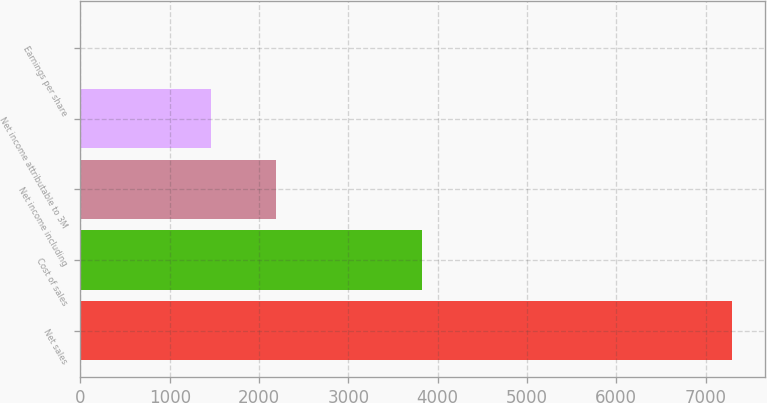<chart> <loc_0><loc_0><loc_500><loc_500><bar_chart><fcel>Net sales<fcel>Cost of sales<fcel>Net income including<fcel>Net income attributable to 3M<fcel>Earnings per share<nl><fcel>7298<fcel>3827<fcel>2190.55<fcel>1460.92<fcel>1.66<nl></chart> 